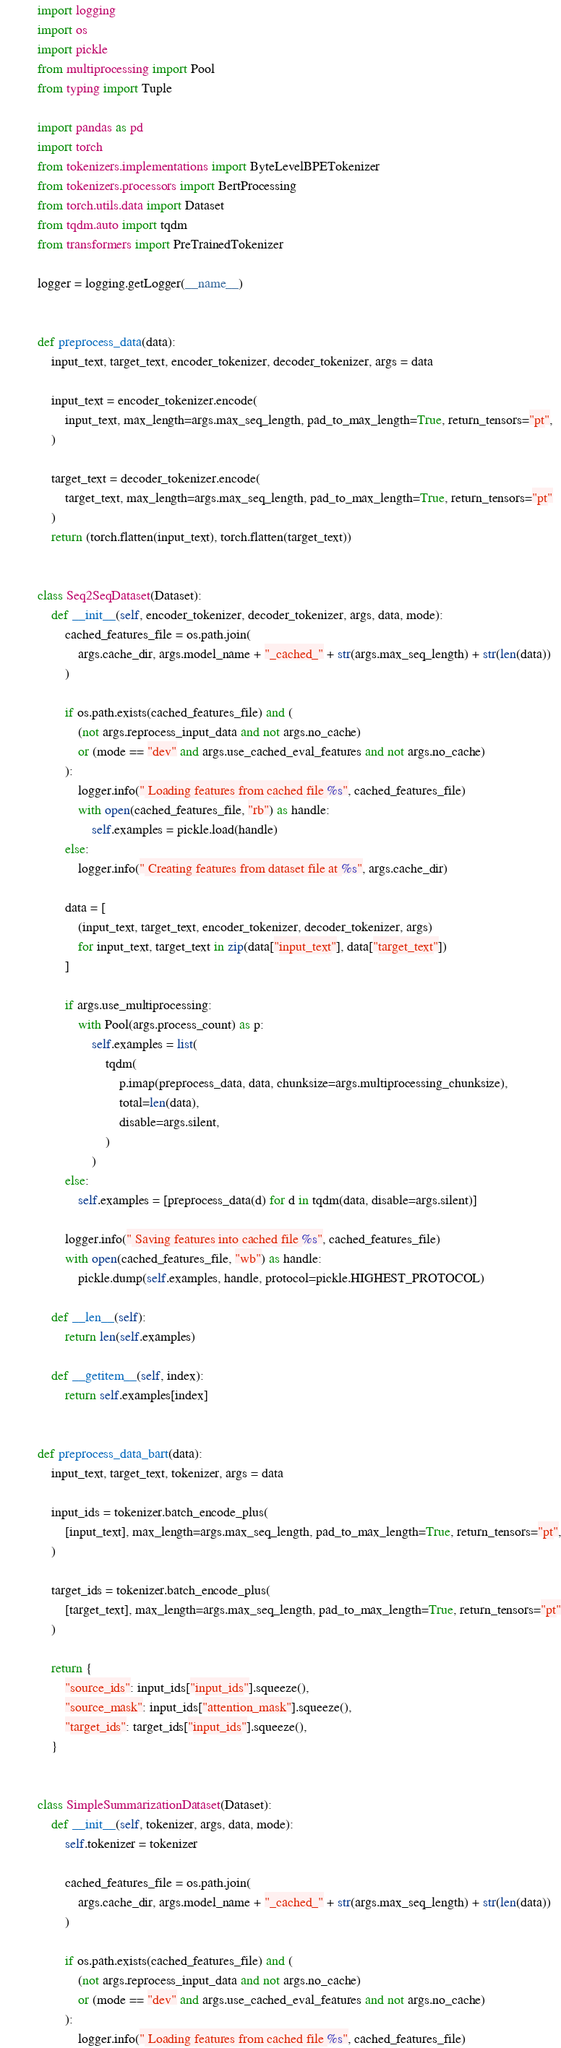Convert code to text. <code><loc_0><loc_0><loc_500><loc_500><_Python_>import logging
import os
import pickle
from multiprocessing import Pool
from typing import Tuple

import pandas as pd
import torch
from tokenizers.implementations import ByteLevelBPETokenizer
from tokenizers.processors import BertProcessing
from torch.utils.data import Dataset
from tqdm.auto import tqdm
from transformers import PreTrainedTokenizer

logger = logging.getLogger(__name__)


def preprocess_data(data):
    input_text, target_text, encoder_tokenizer, decoder_tokenizer, args = data

    input_text = encoder_tokenizer.encode(
        input_text, max_length=args.max_seq_length, pad_to_max_length=True, return_tensors="pt",
    )

    target_text = decoder_tokenizer.encode(
        target_text, max_length=args.max_seq_length, pad_to_max_length=True, return_tensors="pt"
    )
    return (torch.flatten(input_text), torch.flatten(target_text))


class Seq2SeqDataset(Dataset):
    def __init__(self, encoder_tokenizer, decoder_tokenizer, args, data, mode):
        cached_features_file = os.path.join(
            args.cache_dir, args.model_name + "_cached_" + str(args.max_seq_length) + str(len(data))
        )

        if os.path.exists(cached_features_file) and (
            (not args.reprocess_input_data and not args.no_cache)
            or (mode == "dev" and args.use_cached_eval_features and not args.no_cache)
        ):
            logger.info(" Loading features from cached file %s", cached_features_file)
            with open(cached_features_file, "rb") as handle:
                self.examples = pickle.load(handle)
        else:
            logger.info(" Creating features from dataset file at %s", args.cache_dir)

        data = [
            (input_text, target_text, encoder_tokenizer, decoder_tokenizer, args)
            for input_text, target_text in zip(data["input_text"], data["target_text"])
        ]

        if args.use_multiprocessing:
            with Pool(args.process_count) as p:
                self.examples = list(
                    tqdm(
                        p.imap(preprocess_data, data, chunksize=args.multiprocessing_chunksize),
                        total=len(data),
                        disable=args.silent,
                    )
                )
        else:
            self.examples = [preprocess_data(d) for d in tqdm(data, disable=args.silent)]

        logger.info(" Saving features into cached file %s", cached_features_file)
        with open(cached_features_file, "wb") as handle:
            pickle.dump(self.examples, handle, protocol=pickle.HIGHEST_PROTOCOL)

    def __len__(self):
        return len(self.examples)

    def __getitem__(self, index):
        return self.examples[index]


def preprocess_data_bart(data):
    input_text, target_text, tokenizer, args = data

    input_ids = tokenizer.batch_encode_plus(
        [input_text], max_length=args.max_seq_length, pad_to_max_length=True, return_tensors="pt",
    )

    target_ids = tokenizer.batch_encode_plus(
        [target_text], max_length=args.max_seq_length, pad_to_max_length=True, return_tensors="pt"
    )

    return {
        "source_ids": input_ids["input_ids"].squeeze(),
        "source_mask": input_ids["attention_mask"].squeeze(),
        "target_ids": target_ids["input_ids"].squeeze(),
    }


class SimpleSummarizationDataset(Dataset):
    def __init__(self, tokenizer, args, data, mode):
        self.tokenizer = tokenizer

        cached_features_file = os.path.join(
            args.cache_dir, args.model_name + "_cached_" + str(args.max_seq_length) + str(len(data))
        )

        if os.path.exists(cached_features_file) and (
            (not args.reprocess_input_data and not args.no_cache)
            or (mode == "dev" and args.use_cached_eval_features and not args.no_cache)
        ):
            logger.info(" Loading features from cached file %s", cached_features_file)</code> 